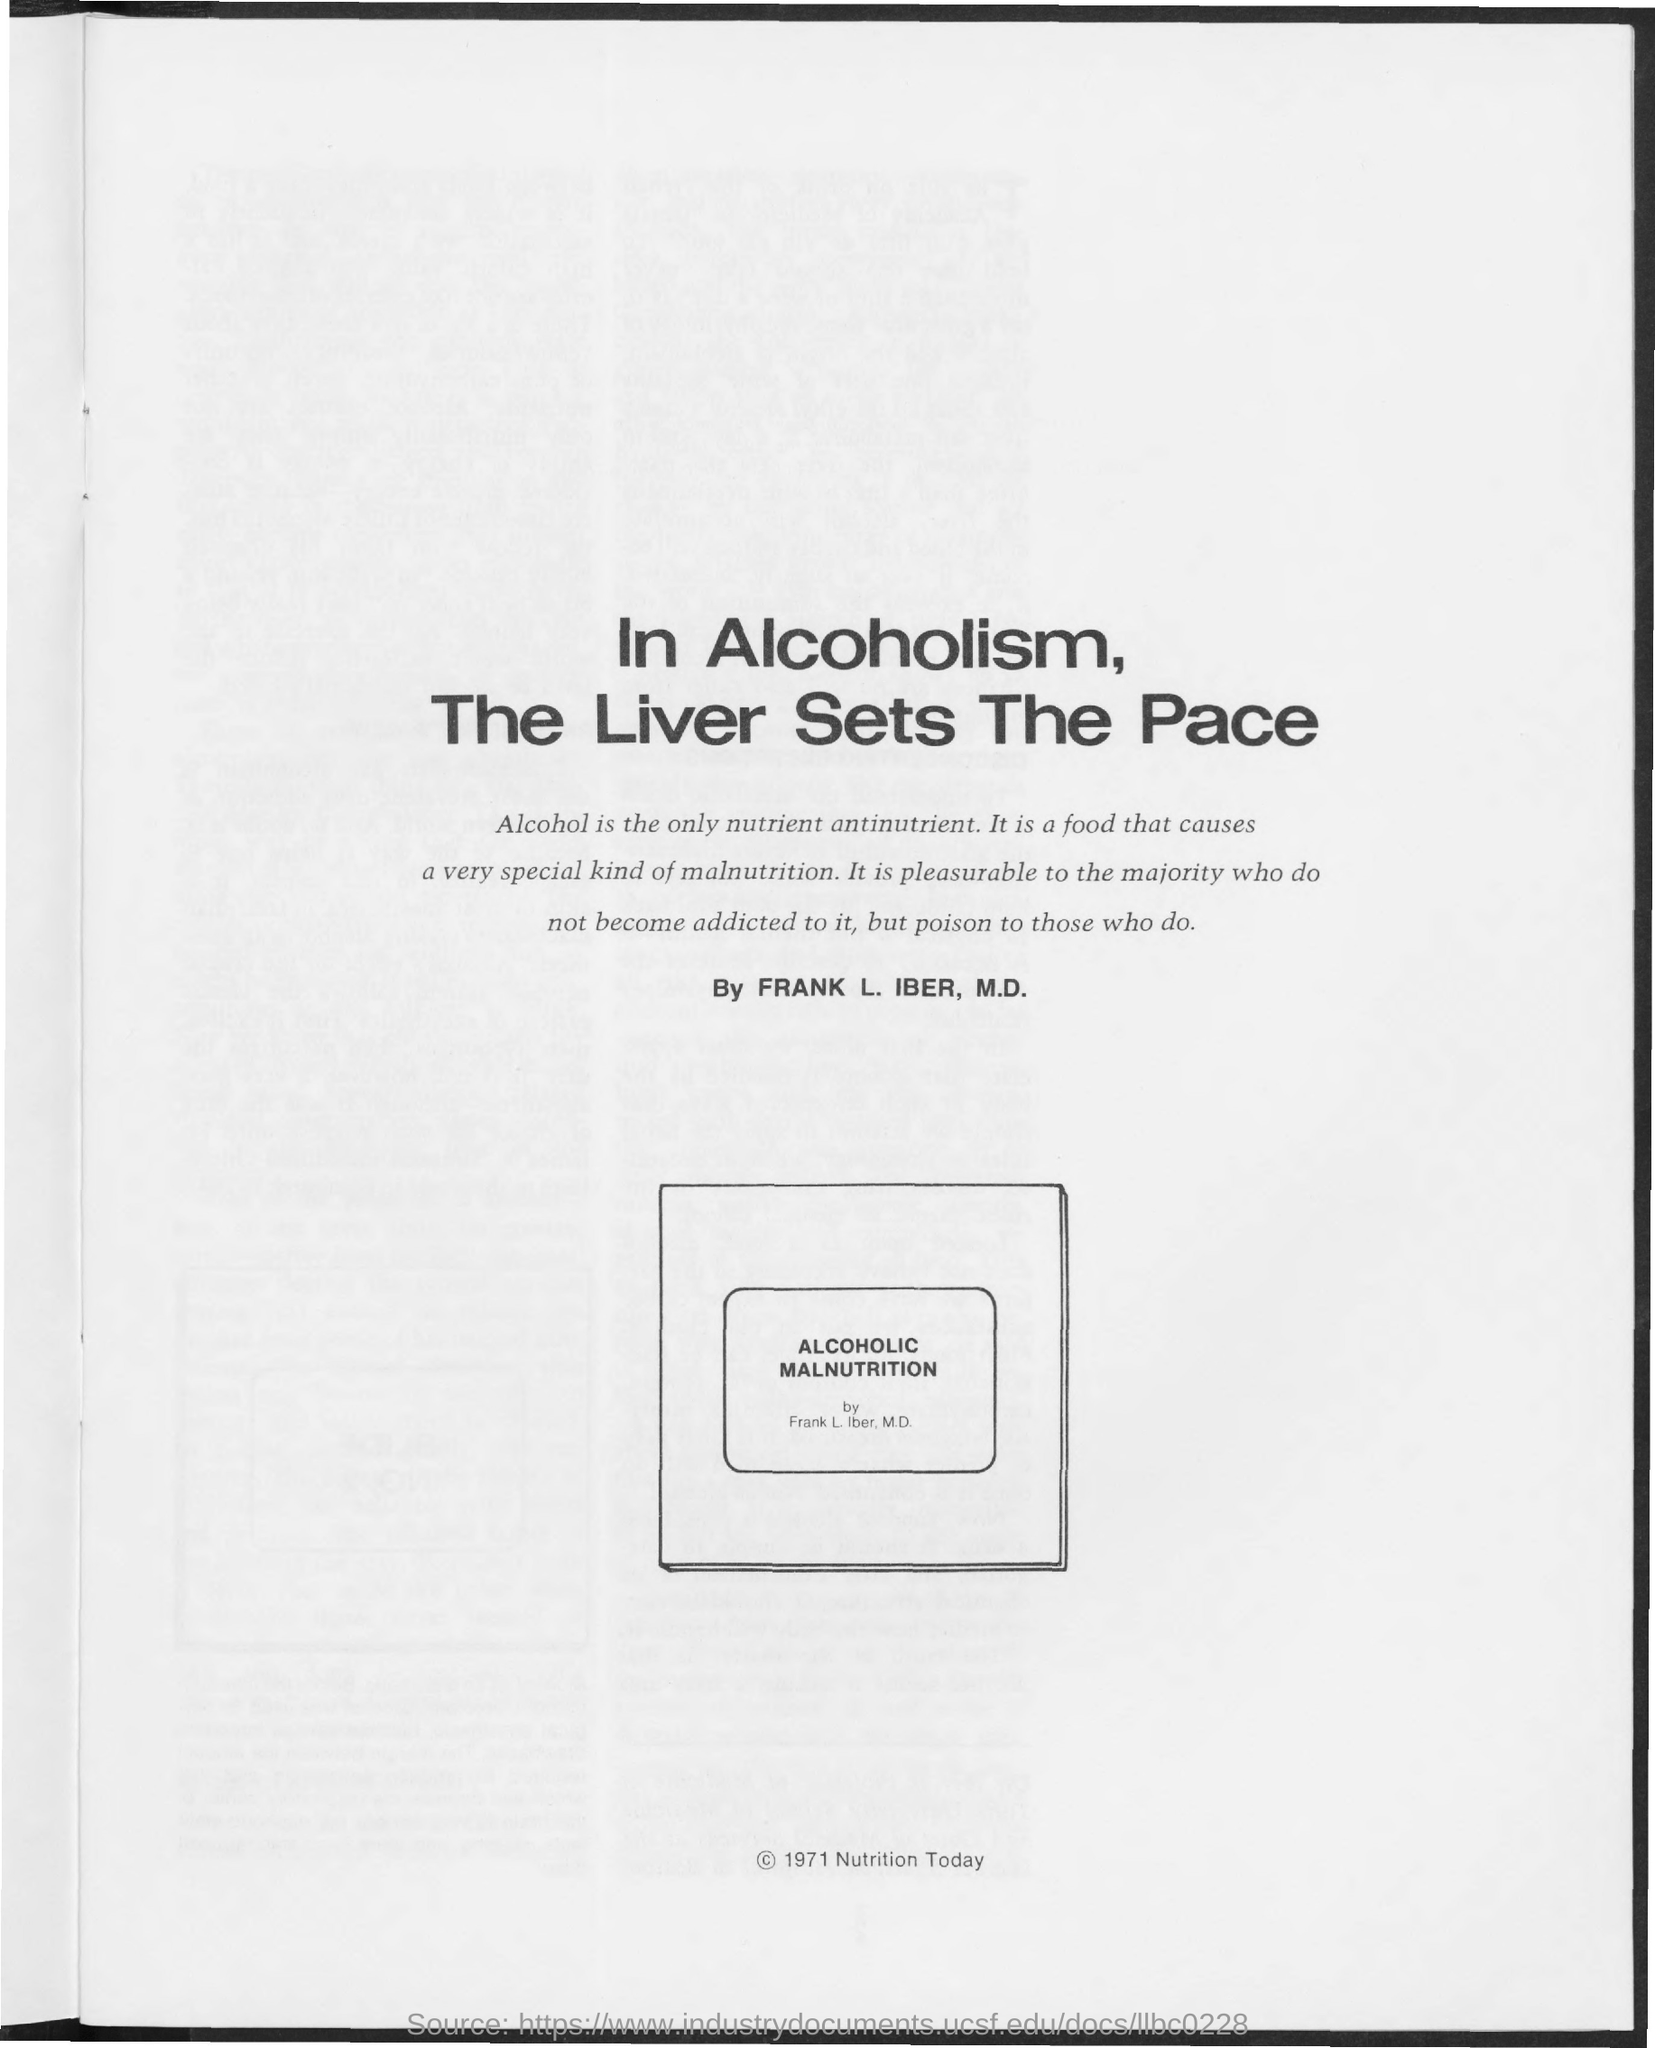What is the only nutrient antinutrient according to Frank L. Iber, M.D.?
Offer a terse response. Alcohol. 